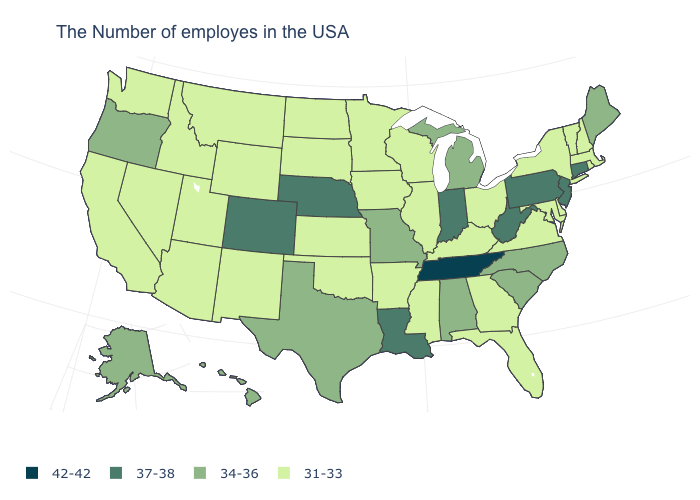Name the states that have a value in the range 31-33?
Be succinct. Massachusetts, Rhode Island, New Hampshire, Vermont, New York, Delaware, Maryland, Virginia, Ohio, Florida, Georgia, Kentucky, Wisconsin, Illinois, Mississippi, Arkansas, Minnesota, Iowa, Kansas, Oklahoma, South Dakota, North Dakota, Wyoming, New Mexico, Utah, Montana, Arizona, Idaho, Nevada, California, Washington. What is the value of Rhode Island?
Give a very brief answer. 31-33. Does the first symbol in the legend represent the smallest category?
Answer briefly. No. What is the value of Massachusetts?
Answer briefly. 31-33. Does Arizona have a lower value than Tennessee?
Be succinct. Yes. Does the map have missing data?
Give a very brief answer. No. What is the lowest value in the Northeast?
Give a very brief answer. 31-33. What is the highest value in the South ?
Give a very brief answer. 42-42. Does Connecticut have the highest value in the USA?
Concise answer only. No. Does Delaware have the lowest value in the South?
Quick response, please. Yes. Which states hav the highest value in the MidWest?
Keep it brief. Indiana, Nebraska. Does Maine have the lowest value in the USA?
Give a very brief answer. No. What is the highest value in the Northeast ?
Be succinct. 37-38. Does Alabama have a lower value than Virginia?
Give a very brief answer. No. What is the value of Nevada?
Concise answer only. 31-33. 